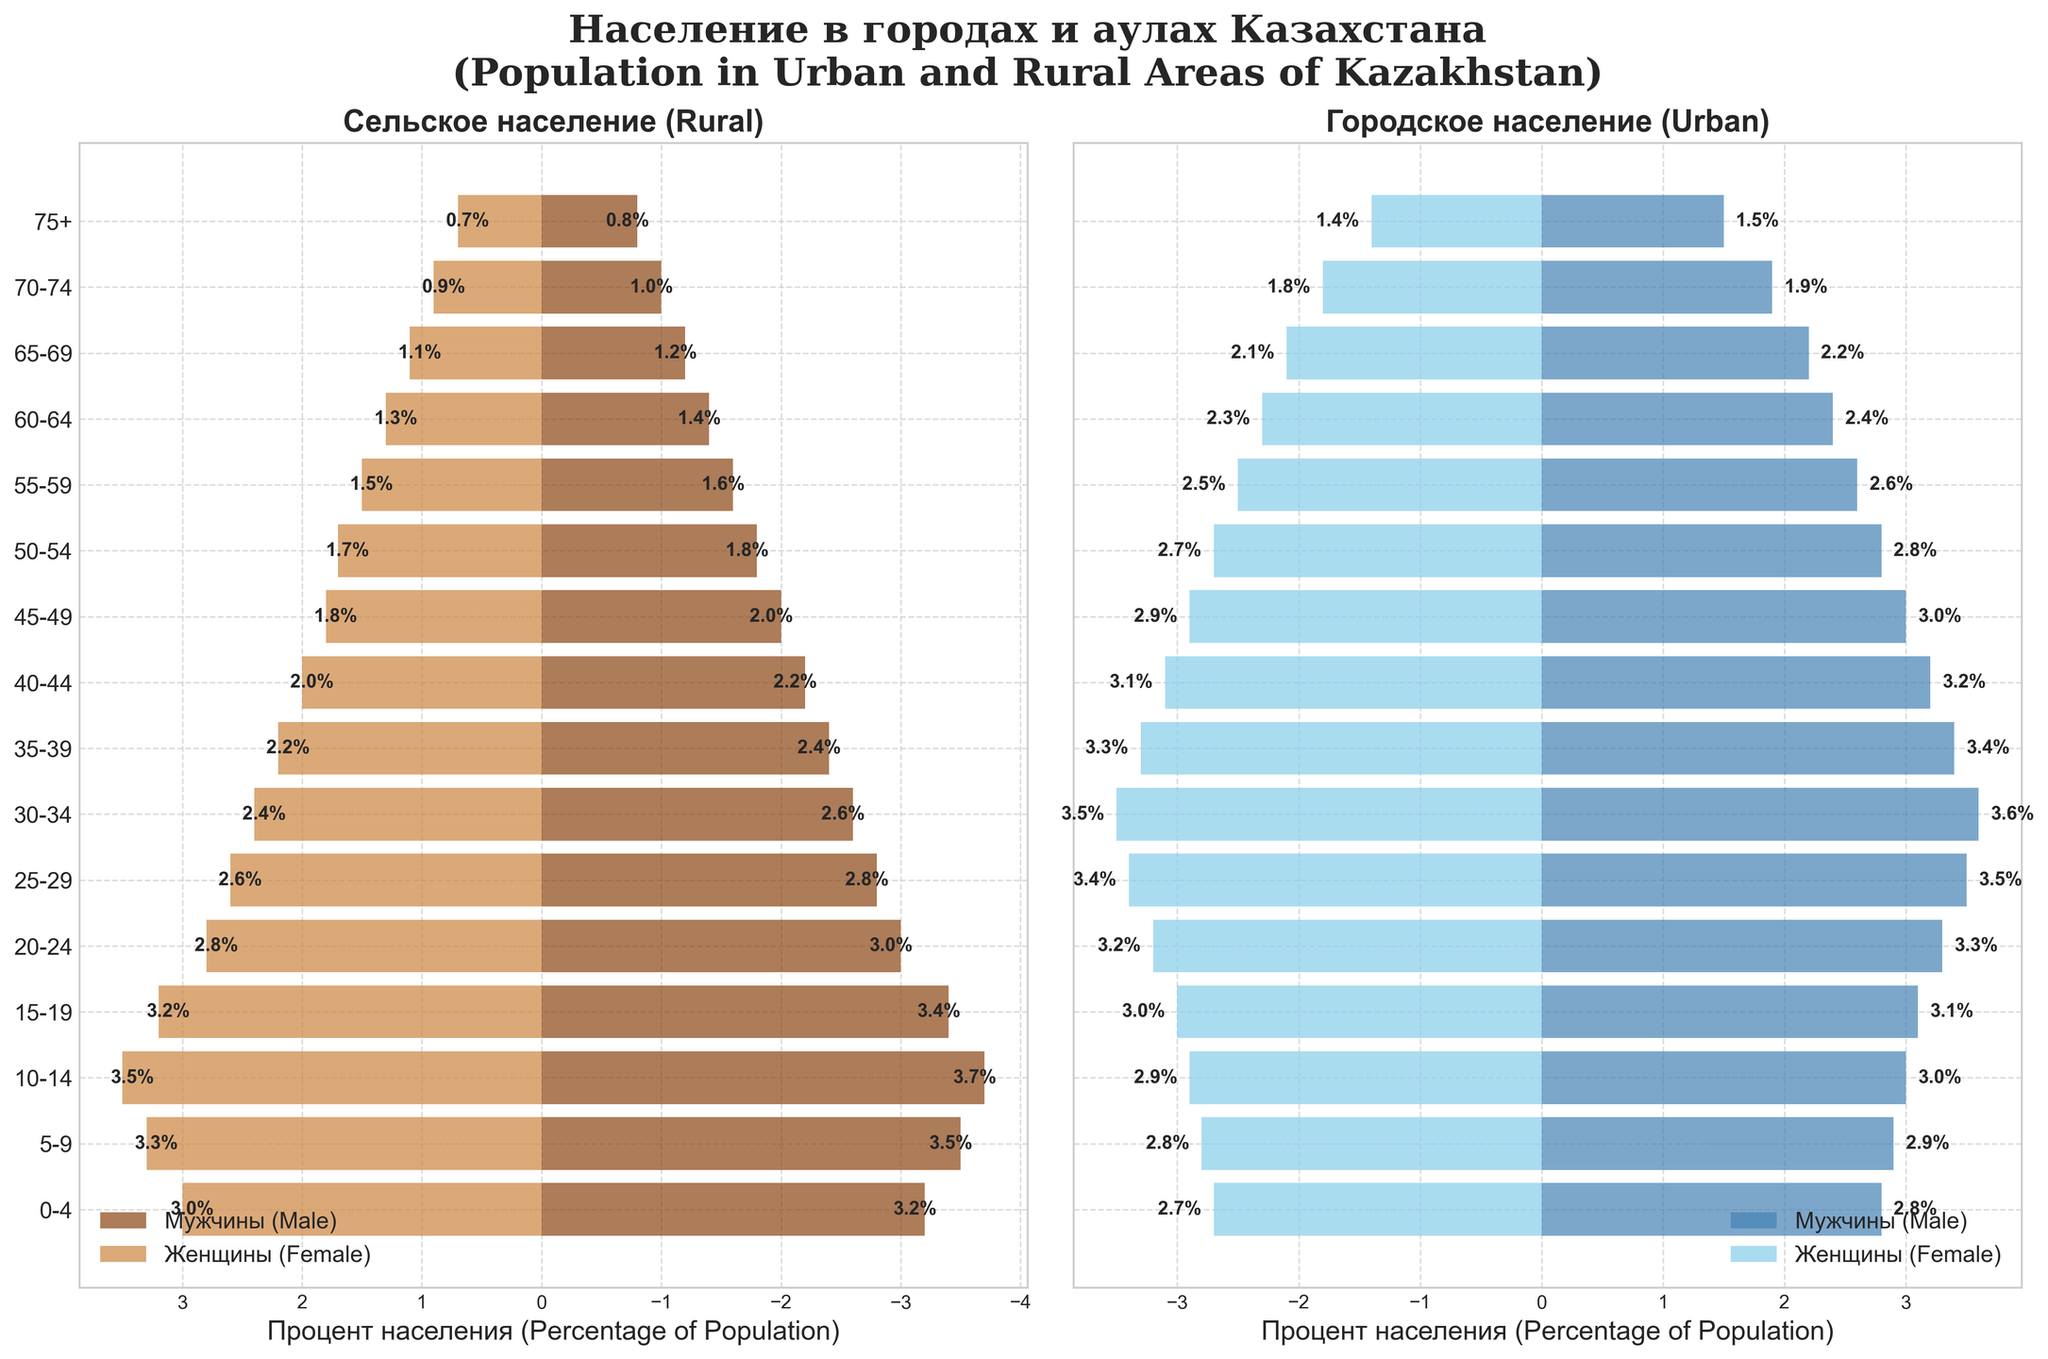How is the population distributed between males and females in rural areas for the age group 0-4? The figure shows a horizontal bar where Rural Male is -3.2% and Rural Female is 3.0% for the age group 0-4. The negative sign indicates it's on the left side of the y-axis.
Answer: Rural Male: 3.2%, Rural Female: 3.0% What is the title of the figure? The title is displayed at the top center of the figure in bold text.
Answer: Population in Urban and Rural Areas of Kazakhstan Which age group has the highest population percentage for rural males? We compare the percentages for rural males across all age groups and identify the highest value, which is 3.7% for the age group 10-14.
Answer: 10-14 Is there a higher percentage of urban females or females aged 25-29? The figure indicates that Urban Female (25-29) is 3.4% while Rural Female (25-29) is 2.6%, so Urban Female has a higher percentage.
Answer: Urban Female Compare the urban and rural male populations aged 55-59. Which is larger? For the 55-59 age group, Urban Male is 2.6% and Rural Male is 1.6%, indicating that Urban Male is larger.
Answer: Urban Male What trend is visible for the urban population as the age increases from 0-4 to 75+? Observing the bars, we see that the population percentage generally decreases as age increases in both males and females in urban areas.
Answer: Decreasing trend What age group shows the most significant difference in population percentages between rural and urban males? We calculate the difference for each age group and find that the age group 30-34 shows the most significant difference: Urban Male (3.6%) - Rural Male (2.6%) = 1.0%.
Answer: 30-34 How does the percentage of rural females aged 70-74 compare to urban females? Rural Female (70-74) is 0.9%, while Urban Female (70-74) is 1.8%, indicating Urban Female is double that of Rural Female.
Answer: Urban Female is higher What is the combined percentage of the rural population in the age group 15-19? Adding Rural Male (3.4%) and Rural Female (3.2%) for the 15-19 age group gives 3.4% + 3.2% = 6.6%.
Answer: 6.6% What distribution pattern do we observe in the 40-44 age group for both rural and urban populations? The figure shows Urban Male (3.2%) and Urban Female (-3.1%) have higher population percentages compared to Rural Male (2.2%) and Rural Female (2.0%), indicating a higher urban population in this age group.
Answer: Higher in urban areas 